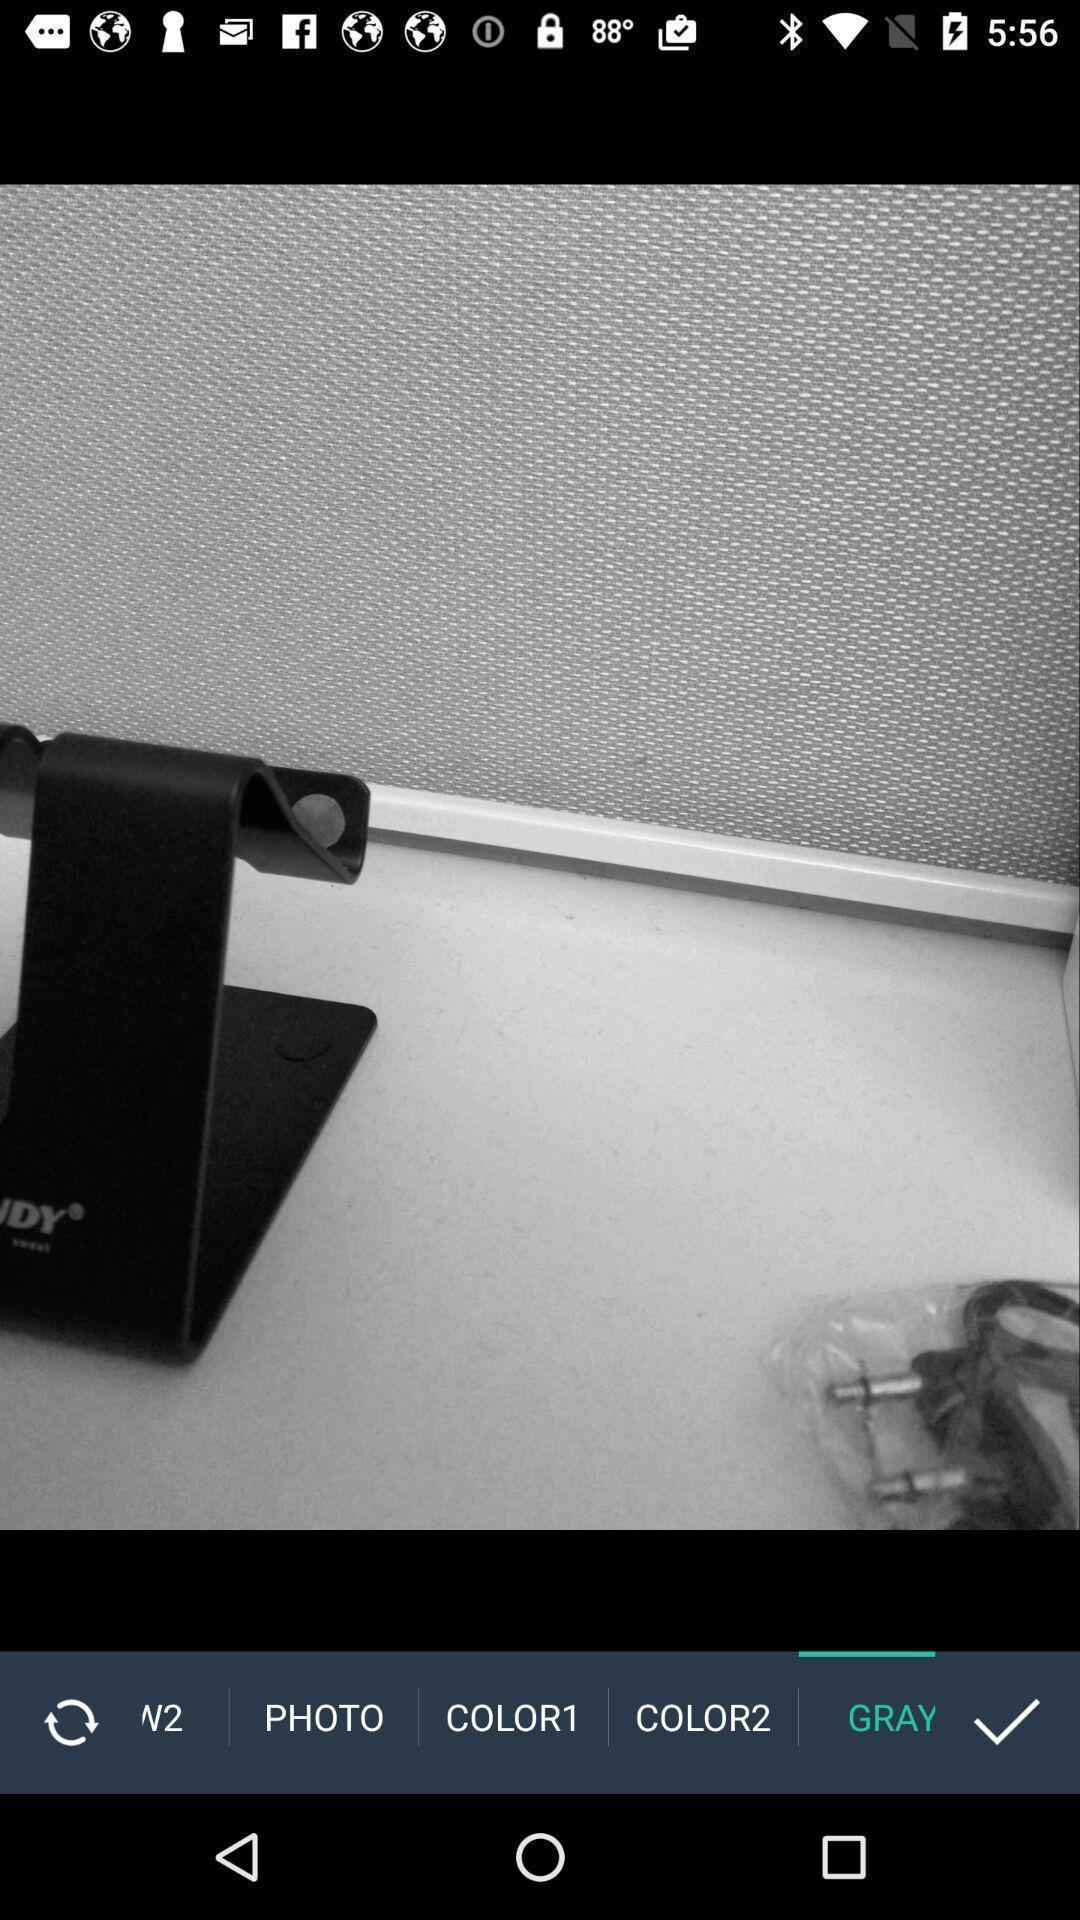Give me a narrative description of this picture. Page displaying with an image in a photo editing app. 